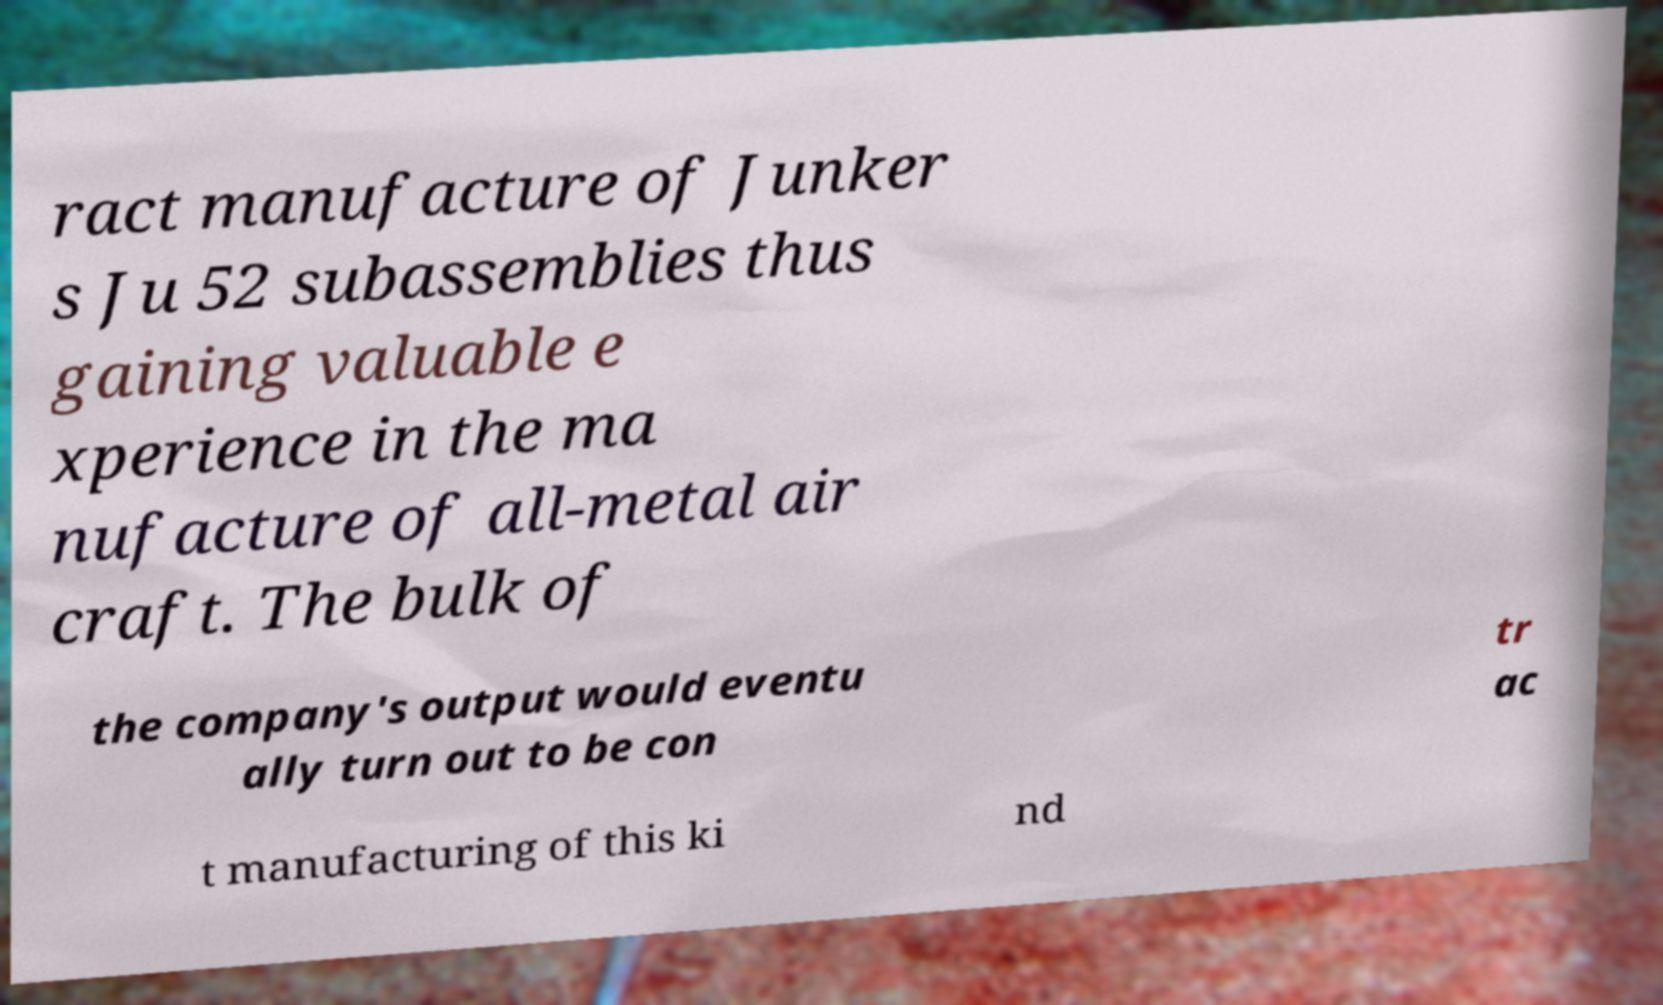What messages or text are displayed in this image? I need them in a readable, typed format. ract manufacture of Junker s Ju 52 subassemblies thus gaining valuable e xperience in the ma nufacture of all-metal air craft. The bulk of the company's output would eventu ally turn out to be con tr ac t manufacturing of this ki nd 